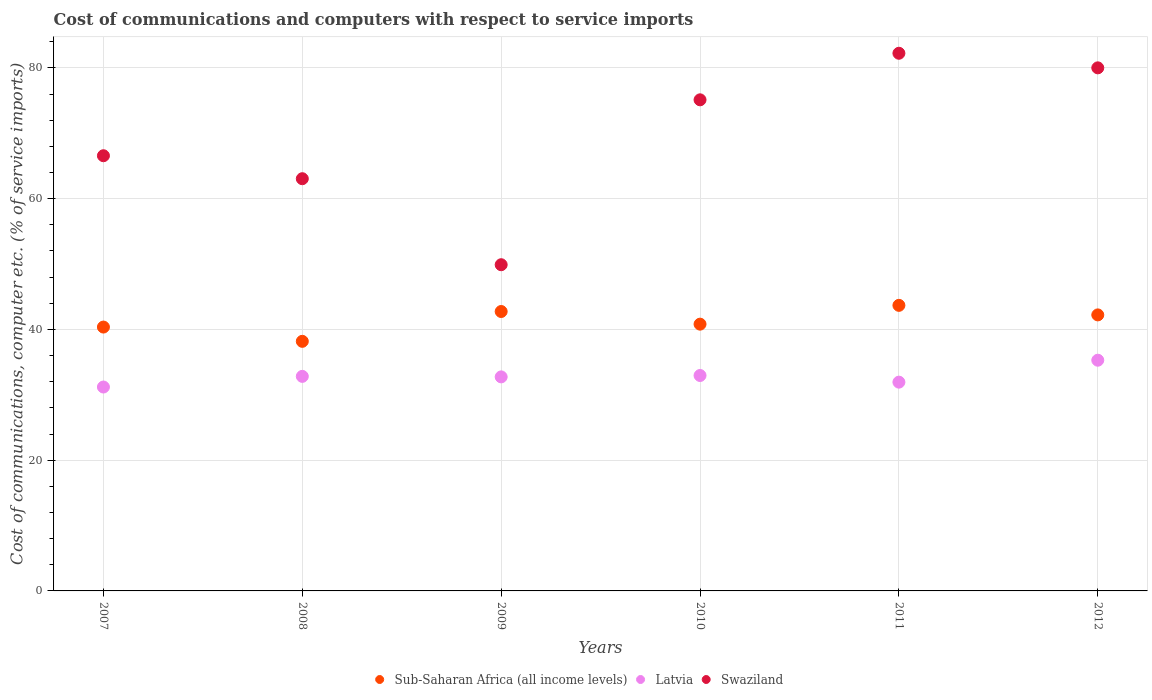How many different coloured dotlines are there?
Your answer should be compact. 3. Is the number of dotlines equal to the number of legend labels?
Your answer should be compact. Yes. What is the cost of communications and computers in Swaziland in 2009?
Provide a succinct answer. 49.9. Across all years, what is the maximum cost of communications and computers in Sub-Saharan Africa (all income levels)?
Your answer should be compact. 43.68. Across all years, what is the minimum cost of communications and computers in Swaziland?
Your answer should be compact. 49.9. In which year was the cost of communications and computers in Swaziland maximum?
Your response must be concise. 2011. In which year was the cost of communications and computers in Latvia minimum?
Your answer should be very brief. 2007. What is the total cost of communications and computers in Sub-Saharan Africa (all income levels) in the graph?
Provide a succinct answer. 248. What is the difference between the cost of communications and computers in Latvia in 2008 and that in 2011?
Offer a terse response. 0.88. What is the difference between the cost of communications and computers in Sub-Saharan Africa (all income levels) in 2008 and the cost of communications and computers in Latvia in 2009?
Keep it short and to the point. 5.44. What is the average cost of communications and computers in Sub-Saharan Africa (all income levels) per year?
Give a very brief answer. 41.33. In the year 2009, what is the difference between the cost of communications and computers in Sub-Saharan Africa (all income levels) and cost of communications and computers in Latvia?
Make the answer very short. 10. In how many years, is the cost of communications and computers in Latvia greater than 4 %?
Your response must be concise. 6. What is the ratio of the cost of communications and computers in Latvia in 2007 to that in 2012?
Offer a terse response. 0.88. Is the difference between the cost of communications and computers in Sub-Saharan Africa (all income levels) in 2007 and 2008 greater than the difference between the cost of communications and computers in Latvia in 2007 and 2008?
Your response must be concise. Yes. What is the difference between the highest and the second highest cost of communications and computers in Sub-Saharan Africa (all income levels)?
Your answer should be very brief. 0.94. What is the difference between the highest and the lowest cost of communications and computers in Latvia?
Provide a succinct answer. 4.1. Is the cost of communications and computers in Latvia strictly greater than the cost of communications and computers in Swaziland over the years?
Ensure brevity in your answer.  No. Are the values on the major ticks of Y-axis written in scientific E-notation?
Give a very brief answer. No. Does the graph contain grids?
Make the answer very short. Yes. How are the legend labels stacked?
Your answer should be compact. Horizontal. What is the title of the graph?
Offer a very short reply. Cost of communications and computers with respect to service imports. Does "Nepal" appear as one of the legend labels in the graph?
Your answer should be very brief. No. What is the label or title of the X-axis?
Make the answer very short. Years. What is the label or title of the Y-axis?
Offer a terse response. Cost of communications, computer etc. (% of service imports). What is the Cost of communications, computer etc. (% of service imports) of Sub-Saharan Africa (all income levels) in 2007?
Ensure brevity in your answer.  40.36. What is the Cost of communications, computer etc. (% of service imports) of Latvia in 2007?
Provide a succinct answer. 31.19. What is the Cost of communications, computer etc. (% of service imports) in Swaziland in 2007?
Offer a very short reply. 66.57. What is the Cost of communications, computer etc. (% of service imports) of Sub-Saharan Africa (all income levels) in 2008?
Give a very brief answer. 38.18. What is the Cost of communications, computer etc. (% of service imports) in Latvia in 2008?
Offer a terse response. 32.82. What is the Cost of communications, computer etc. (% of service imports) in Swaziland in 2008?
Make the answer very short. 63.06. What is the Cost of communications, computer etc. (% of service imports) in Sub-Saharan Africa (all income levels) in 2009?
Give a very brief answer. 42.74. What is the Cost of communications, computer etc. (% of service imports) of Latvia in 2009?
Ensure brevity in your answer.  32.74. What is the Cost of communications, computer etc. (% of service imports) in Swaziland in 2009?
Your answer should be very brief. 49.9. What is the Cost of communications, computer etc. (% of service imports) of Sub-Saharan Africa (all income levels) in 2010?
Ensure brevity in your answer.  40.81. What is the Cost of communications, computer etc. (% of service imports) in Latvia in 2010?
Provide a succinct answer. 32.95. What is the Cost of communications, computer etc. (% of service imports) of Swaziland in 2010?
Your answer should be very brief. 75.13. What is the Cost of communications, computer etc. (% of service imports) in Sub-Saharan Africa (all income levels) in 2011?
Ensure brevity in your answer.  43.68. What is the Cost of communications, computer etc. (% of service imports) in Latvia in 2011?
Ensure brevity in your answer.  31.94. What is the Cost of communications, computer etc. (% of service imports) of Swaziland in 2011?
Your response must be concise. 82.25. What is the Cost of communications, computer etc. (% of service imports) of Sub-Saharan Africa (all income levels) in 2012?
Ensure brevity in your answer.  42.22. What is the Cost of communications, computer etc. (% of service imports) of Latvia in 2012?
Provide a succinct answer. 35.29. What is the Cost of communications, computer etc. (% of service imports) in Swaziland in 2012?
Offer a terse response. 80.02. Across all years, what is the maximum Cost of communications, computer etc. (% of service imports) in Sub-Saharan Africa (all income levels)?
Ensure brevity in your answer.  43.68. Across all years, what is the maximum Cost of communications, computer etc. (% of service imports) in Latvia?
Give a very brief answer. 35.29. Across all years, what is the maximum Cost of communications, computer etc. (% of service imports) of Swaziland?
Your response must be concise. 82.25. Across all years, what is the minimum Cost of communications, computer etc. (% of service imports) of Sub-Saharan Africa (all income levels)?
Make the answer very short. 38.18. Across all years, what is the minimum Cost of communications, computer etc. (% of service imports) in Latvia?
Your answer should be very brief. 31.19. Across all years, what is the minimum Cost of communications, computer etc. (% of service imports) in Swaziland?
Give a very brief answer. 49.9. What is the total Cost of communications, computer etc. (% of service imports) in Sub-Saharan Africa (all income levels) in the graph?
Your response must be concise. 248. What is the total Cost of communications, computer etc. (% of service imports) of Latvia in the graph?
Make the answer very short. 196.94. What is the total Cost of communications, computer etc. (% of service imports) in Swaziland in the graph?
Keep it short and to the point. 416.92. What is the difference between the Cost of communications, computer etc. (% of service imports) of Sub-Saharan Africa (all income levels) in 2007 and that in 2008?
Give a very brief answer. 2.18. What is the difference between the Cost of communications, computer etc. (% of service imports) of Latvia in 2007 and that in 2008?
Your answer should be compact. -1.63. What is the difference between the Cost of communications, computer etc. (% of service imports) of Swaziland in 2007 and that in 2008?
Offer a terse response. 3.51. What is the difference between the Cost of communications, computer etc. (% of service imports) in Sub-Saharan Africa (all income levels) in 2007 and that in 2009?
Offer a terse response. -2.38. What is the difference between the Cost of communications, computer etc. (% of service imports) in Latvia in 2007 and that in 2009?
Your answer should be compact. -1.55. What is the difference between the Cost of communications, computer etc. (% of service imports) of Swaziland in 2007 and that in 2009?
Give a very brief answer. 16.67. What is the difference between the Cost of communications, computer etc. (% of service imports) of Sub-Saharan Africa (all income levels) in 2007 and that in 2010?
Provide a short and direct response. -0.45. What is the difference between the Cost of communications, computer etc. (% of service imports) in Latvia in 2007 and that in 2010?
Make the answer very short. -1.76. What is the difference between the Cost of communications, computer etc. (% of service imports) in Swaziland in 2007 and that in 2010?
Give a very brief answer. -8.55. What is the difference between the Cost of communications, computer etc. (% of service imports) of Sub-Saharan Africa (all income levels) in 2007 and that in 2011?
Your response must be concise. -3.32. What is the difference between the Cost of communications, computer etc. (% of service imports) of Latvia in 2007 and that in 2011?
Your response must be concise. -0.75. What is the difference between the Cost of communications, computer etc. (% of service imports) of Swaziland in 2007 and that in 2011?
Ensure brevity in your answer.  -15.68. What is the difference between the Cost of communications, computer etc. (% of service imports) of Sub-Saharan Africa (all income levels) in 2007 and that in 2012?
Provide a succinct answer. -1.86. What is the difference between the Cost of communications, computer etc. (% of service imports) of Latvia in 2007 and that in 2012?
Ensure brevity in your answer.  -4.1. What is the difference between the Cost of communications, computer etc. (% of service imports) in Swaziland in 2007 and that in 2012?
Provide a succinct answer. -13.44. What is the difference between the Cost of communications, computer etc. (% of service imports) in Sub-Saharan Africa (all income levels) in 2008 and that in 2009?
Make the answer very short. -4.56. What is the difference between the Cost of communications, computer etc. (% of service imports) in Latvia in 2008 and that in 2009?
Your answer should be compact. 0.08. What is the difference between the Cost of communications, computer etc. (% of service imports) of Swaziland in 2008 and that in 2009?
Your answer should be compact. 13.16. What is the difference between the Cost of communications, computer etc. (% of service imports) of Sub-Saharan Africa (all income levels) in 2008 and that in 2010?
Ensure brevity in your answer.  -2.63. What is the difference between the Cost of communications, computer etc. (% of service imports) of Latvia in 2008 and that in 2010?
Your answer should be compact. -0.13. What is the difference between the Cost of communications, computer etc. (% of service imports) of Swaziland in 2008 and that in 2010?
Your answer should be very brief. -12.07. What is the difference between the Cost of communications, computer etc. (% of service imports) of Sub-Saharan Africa (all income levels) in 2008 and that in 2011?
Keep it short and to the point. -5.5. What is the difference between the Cost of communications, computer etc. (% of service imports) in Latvia in 2008 and that in 2011?
Ensure brevity in your answer.  0.88. What is the difference between the Cost of communications, computer etc. (% of service imports) of Swaziland in 2008 and that in 2011?
Provide a short and direct response. -19.19. What is the difference between the Cost of communications, computer etc. (% of service imports) of Sub-Saharan Africa (all income levels) in 2008 and that in 2012?
Give a very brief answer. -4.04. What is the difference between the Cost of communications, computer etc. (% of service imports) in Latvia in 2008 and that in 2012?
Your response must be concise. -2.47. What is the difference between the Cost of communications, computer etc. (% of service imports) of Swaziland in 2008 and that in 2012?
Offer a very short reply. -16.96. What is the difference between the Cost of communications, computer etc. (% of service imports) in Sub-Saharan Africa (all income levels) in 2009 and that in 2010?
Provide a short and direct response. 1.93. What is the difference between the Cost of communications, computer etc. (% of service imports) in Latvia in 2009 and that in 2010?
Offer a terse response. -0.21. What is the difference between the Cost of communications, computer etc. (% of service imports) in Swaziland in 2009 and that in 2010?
Offer a very short reply. -25.23. What is the difference between the Cost of communications, computer etc. (% of service imports) in Sub-Saharan Africa (all income levels) in 2009 and that in 2011?
Your answer should be very brief. -0.94. What is the difference between the Cost of communications, computer etc. (% of service imports) in Latvia in 2009 and that in 2011?
Ensure brevity in your answer.  0.81. What is the difference between the Cost of communications, computer etc. (% of service imports) in Swaziland in 2009 and that in 2011?
Ensure brevity in your answer.  -32.35. What is the difference between the Cost of communications, computer etc. (% of service imports) in Sub-Saharan Africa (all income levels) in 2009 and that in 2012?
Your answer should be compact. 0.52. What is the difference between the Cost of communications, computer etc. (% of service imports) in Latvia in 2009 and that in 2012?
Keep it short and to the point. -2.55. What is the difference between the Cost of communications, computer etc. (% of service imports) of Swaziland in 2009 and that in 2012?
Make the answer very short. -30.12. What is the difference between the Cost of communications, computer etc. (% of service imports) of Sub-Saharan Africa (all income levels) in 2010 and that in 2011?
Offer a very short reply. -2.88. What is the difference between the Cost of communications, computer etc. (% of service imports) in Latvia in 2010 and that in 2011?
Ensure brevity in your answer.  1.02. What is the difference between the Cost of communications, computer etc. (% of service imports) in Swaziland in 2010 and that in 2011?
Provide a succinct answer. -7.12. What is the difference between the Cost of communications, computer etc. (% of service imports) in Sub-Saharan Africa (all income levels) in 2010 and that in 2012?
Provide a succinct answer. -1.42. What is the difference between the Cost of communications, computer etc. (% of service imports) of Latvia in 2010 and that in 2012?
Your answer should be compact. -2.34. What is the difference between the Cost of communications, computer etc. (% of service imports) of Swaziland in 2010 and that in 2012?
Make the answer very short. -4.89. What is the difference between the Cost of communications, computer etc. (% of service imports) in Sub-Saharan Africa (all income levels) in 2011 and that in 2012?
Give a very brief answer. 1.46. What is the difference between the Cost of communications, computer etc. (% of service imports) of Latvia in 2011 and that in 2012?
Offer a very short reply. -3.36. What is the difference between the Cost of communications, computer etc. (% of service imports) in Swaziland in 2011 and that in 2012?
Offer a terse response. 2.23. What is the difference between the Cost of communications, computer etc. (% of service imports) in Sub-Saharan Africa (all income levels) in 2007 and the Cost of communications, computer etc. (% of service imports) in Latvia in 2008?
Keep it short and to the point. 7.54. What is the difference between the Cost of communications, computer etc. (% of service imports) in Sub-Saharan Africa (all income levels) in 2007 and the Cost of communications, computer etc. (% of service imports) in Swaziland in 2008?
Ensure brevity in your answer.  -22.69. What is the difference between the Cost of communications, computer etc. (% of service imports) in Latvia in 2007 and the Cost of communications, computer etc. (% of service imports) in Swaziland in 2008?
Your answer should be compact. -31.87. What is the difference between the Cost of communications, computer etc. (% of service imports) in Sub-Saharan Africa (all income levels) in 2007 and the Cost of communications, computer etc. (% of service imports) in Latvia in 2009?
Ensure brevity in your answer.  7.62. What is the difference between the Cost of communications, computer etc. (% of service imports) in Sub-Saharan Africa (all income levels) in 2007 and the Cost of communications, computer etc. (% of service imports) in Swaziland in 2009?
Provide a succinct answer. -9.54. What is the difference between the Cost of communications, computer etc. (% of service imports) of Latvia in 2007 and the Cost of communications, computer etc. (% of service imports) of Swaziland in 2009?
Provide a succinct answer. -18.71. What is the difference between the Cost of communications, computer etc. (% of service imports) of Sub-Saharan Africa (all income levels) in 2007 and the Cost of communications, computer etc. (% of service imports) of Latvia in 2010?
Provide a succinct answer. 7.41. What is the difference between the Cost of communications, computer etc. (% of service imports) of Sub-Saharan Africa (all income levels) in 2007 and the Cost of communications, computer etc. (% of service imports) of Swaziland in 2010?
Provide a succinct answer. -34.76. What is the difference between the Cost of communications, computer etc. (% of service imports) in Latvia in 2007 and the Cost of communications, computer etc. (% of service imports) in Swaziland in 2010?
Ensure brevity in your answer.  -43.93. What is the difference between the Cost of communications, computer etc. (% of service imports) in Sub-Saharan Africa (all income levels) in 2007 and the Cost of communications, computer etc. (% of service imports) in Latvia in 2011?
Offer a very short reply. 8.43. What is the difference between the Cost of communications, computer etc. (% of service imports) of Sub-Saharan Africa (all income levels) in 2007 and the Cost of communications, computer etc. (% of service imports) of Swaziland in 2011?
Keep it short and to the point. -41.88. What is the difference between the Cost of communications, computer etc. (% of service imports) in Latvia in 2007 and the Cost of communications, computer etc. (% of service imports) in Swaziland in 2011?
Ensure brevity in your answer.  -51.06. What is the difference between the Cost of communications, computer etc. (% of service imports) in Sub-Saharan Africa (all income levels) in 2007 and the Cost of communications, computer etc. (% of service imports) in Latvia in 2012?
Make the answer very short. 5.07. What is the difference between the Cost of communications, computer etc. (% of service imports) in Sub-Saharan Africa (all income levels) in 2007 and the Cost of communications, computer etc. (% of service imports) in Swaziland in 2012?
Make the answer very short. -39.65. What is the difference between the Cost of communications, computer etc. (% of service imports) of Latvia in 2007 and the Cost of communications, computer etc. (% of service imports) of Swaziland in 2012?
Offer a very short reply. -48.83. What is the difference between the Cost of communications, computer etc. (% of service imports) of Sub-Saharan Africa (all income levels) in 2008 and the Cost of communications, computer etc. (% of service imports) of Latvia in 2009?
Your answer should be compact. 5.44. What is the difference between the Cost of communications, computer etc. (% of service imports) of Sub-Saharan Africa (all income levels) in 2008 and the Cost of communications, computer etc. (% of service imports) of Swaziland in 2009?
Give a very brief answer. -11.72. What is the difference between the Cost of communications, computer etc. (% of service imports) of Latvia in 2008 and the Cost of communications, computer etc. (% of service imports) of Swaziland in 2009?
Provide a short and direct response. -17.08. What is the difference between the Cost of communications, computer etc. (% of service imports) in Sub-Saharan Africa (all income levels) in 2008 and the Cost of communications, computer etc. (% of service imports) in Latvia in 2010?
Provide a succinct answer. 5.23. What is the difference between the Cost of communications, computer etc. (% of service imports) in Sub-Saharan Africa (all income levels) in 2008 and the Cost of communications, computer etc. (% of service imports) in Swaziland in 2010?
Provide a short and direct response. -36.95. What is the difference between the Cost of communications, computer etc. (% of service imports) of Latvia in 2008 and the Cost of communications, computer etc. (% of service imports) of Swaziland in 2010?
Keep it short and to the point. -42.31. What is the difference between the Cost of communications, computer etc. (% of service imports) in Sub-Saharan Africa (all income levels) in 2008 and the Cost of communications, computer etc. (% of service imports) in Latvia in 2011?
Give a very brief answer. 6.24. What is the difference between the Cost of communications, computer etc. (% of service imports) in Sub-Saharan Africa (all income levels) in 2008 and the Cost of communications, computer etc. (% of service imports) in Swaziland in 2011?
Give a very brief answer. -44.07. What is the difference between the Cost of communications, computer etc. (% of service imports) in Latvia in 2008 and the Cost of communications, computer etc. (% of service imports) in Swaziland in 2011?
Your answer should be compact. -49.43. What is the difference between the Cost of communications, computer etc. (% of service imports) in Sub-Saharan Africa (all income levels) in 2008 and the Cost of communications, computer etc. (% of service imports) in Latvia in 2012?
Ensure brevity in your answer.  2.89. What is the difference between the Cost of communications, computer etc. (% of service imports) of Sub-Saharan Africa (all income levels) in 2008 and the Cost of communications, computer etc. (% of service imports) of Swaziland in 2012?
Your answer should be compact. -41.84. What is the difference between the Cost of communications, computer etc. (% of service imports) in Latvia in 2008 and the Cost of communications, computer etc. (% of service imports) in Swaziland in 2012?
Ensure brevity in your answer.  -47.2. What is the difference between the Cost of communications, computer etc. (% of service imports) in Sub-Saharan Africa (all income levels) in 2009 and the Cost of communications, computer etc. (% of service imports) in Latvia in 2010?
Keep it short and to the point. 9.79. What is the difference between the Cost of communications, computer etc. (% of service imports) of Sub-Saharan Africa (all income levels) in 2009 and the Cost of communications, computer etc. (% of service imports) of Swaziland in 2010?
Offer a terse response. -32.38. What is the difference between the Cost of communications, computer etc. (% of service imports) in Latvia in 2009 and the Cost of communications, computer etc. (% of service imports) in Swaziland in 2010?
Your answer should be very brief. -42.38. What is the difference between the Cost of communications, computer etc. (% of service imports) in Sub-Saharan Africa (all income levels) in 2009 and the Cost of communications, computer etc. (% of service imports) in Latvia in 2011?
Offer a very short reply. 10.81. What is the difference between the Cost of communications, computer etc. (% of service imports) in Sub-Saharan Africa (all income levels) in 2009 and the Cost of communications, computer etc. (% of service imports) in Swaziland in 2011?
Keep it short and to the point. -39.51. What is the difference between the Cost of communications, computer etc. (% of service imports) of Latvia in 2009 and the Cost of communications, computer etc. (% of service imports) of Swaziland in 2011?
Your answer should be very brief. -49.51. What is the difference between the Cost of communications, computer etc. (% of service imports) of Sub-Saharan Africa (all income levels) in 2009 and the Cost of communications, computer etc. (% of service imports) of Latvia in 2012?
Offer a very short reply. 7.45. What is the difference between the Cost of communications, computer etc. (% of service imports) of Sub-Saharan Africa (all income levels) in 2009 and the Cost of communications, computer etc. (% of service imports) of Swaziland in 2012?
Your answer should be compact. -37.27. What is the difference between the Cost of communications, computer etc. (% of service imports) in Latvia in 2009 and the Cost of communications, computer etc. (% of service imports) in Swaziland in 2012?
Make the answer very short. -47.27. What is the difference between the Cost of communications, computer etc. (% of service imports) in Sub-Saharan Africa (all income levels) in 2010 and the Cost of communications, computer etc. (% of service imports) in Latvia in 2011?
Give a very brief answer. 8.87. What is the difference between the Cost of communications, computer etc. (% of service imports) of Sub-Saharan Africa (all income levels) in 2010 and the Cost of communications, computer etc. (% of service imports) of Swaziland in 2011?
Give a very brief answer. -41.44. What is the difference between the Cost of communications, computer etc. (% of service imports) of Latvia in 2010 and the Cost of communications, computer etc. (% of service imports) of Swaziland in 2011?
Your response must be concise. -49.29. What is the difference between the Cost of communications, computer etc. (% of service imports) in Sub-Saharan Africa (all income levels) in 2010 and the Cost of communications, computer etc. (% of service imports) in Latvia in 2012?
Provide a succinct answer. 5.52. What is the difference between the Cost of communications, computer etc. (% of service imports) in Sub-Saharan Africa (all income levels) in 2010 and the Cost of communications, computer etc. (% of service imports) in Swaziland in 2012?
Provide a succinct answer. -39.21. What is the difference between the Cost of communications, computer etc. (% of service imports) of Latvia in 2010 and the Cost of communications, computer etc. (% of service imports) of Swaziland in 2012?
Offer a very short reply. -47.06. What is the difference between the Cost of communications, computer etc. (% of service imports) in Sub-Saharan Africa (all income levels) in 2011 and the Cost of communications, computer etc. (% of service imports) in Latvia in 2012?
Your response must be concise. 8.39. What is the difference between the Cost of communications, computer etc. (% of service imports) in Sub-Saharan Africa (all income levels) in 2011 and the Cost of communications, computer etc. (% of service imports) in Swaziland in 2012?
Your answer should be compact. -36.33. What is the difference between the Cost of communications, computer etc. (% of service imports) in Latvia in 2011 and the Cost of communications, computer etc. (% of service imports) in Swaziland in 2012?
Your response must be concise. -48.08. What is the average Cost of communications, computer etc. (% of service imports) in Sub-Saharan Africa (all income levels) per year?
Provide a succinct answer. 41.33. What is the average Cost of communications, computer etc. (% of service imports) in Latvia per year?
Provide a succinct answer. 32.82. What is the average Cost of communications, computer etc. (% of service imports) in Swaziland per year?
Keep it short and to the point. 69.49. In the year 2007, what is the difference between the Cost of communications, computer etc. (% of service imports) in Sub-Saharan Africa (all income levels) and Cost of communications, computer etc. (% of service imports) in Latvia?
Give a very brief answer. 9.17. In the year 2007, what is the difference between the Cost of communications, computer etc. (% of service imports) in Sub-Saharan Africa (all income levels) and Cost of communications, computer etc. (% of service imports) in Swaziland?
Your response must be concise. -26.21. In the year 2007, what is the difference between the Cost of communications, computer etc. (% of service imports) in Latvia and Cost of communications, computer etc. (% of service imports) in Swaziland?
Keep it short and to the point. -35.38. In the year 2008, what is the difference between the Cost of communications, computer etc. (% of service imports) of Sub-Saharan Africa (all income levels) and Cost of communications, computer etc. (% of service imports) of Latvia?
Offer a terse response. 5.36. In the year 2008, what is the difference between the Cost of communications, computer etc. (% of service imports) of Sub-Saharan Africa (all income levels) and Cost of communications, computer etc. (% of service imports) of Swaziland?
Offer a very short reply. -24.88. In the year 2008, what is the difference between the Cost of communications, computer etc. (% of service imports) of Latvia and Cost of communications, computer etc. (% of service imports) of Swaziland?
Provide a succinct answer. -30.24. In the year 2009, what is the difference between the Cost of communications, computer etc. (% of service imports) in Sub-Saharan Africa (all income levels) and Cost of communications, computer etc. (% of service imports) in Latvia?
Ensure brevity in your answer.  10. In the year 2009, what is the difference between the Cost of communications, computer etc. (% of service imports) of Sub-Saharan Africa (all income levels) and Cost of communications, computer etc. (% of service imports) of Swaziland?
Provide a short and direct response. -7.16. In the year 2009, what is the difference between the Cost of communications, computer etc. (% of service imports) of Latvia and Cost of communications, computer etc. (% of service imports) of Swaziland?
Make the answer very short. -17.16. In the year 2010, what is the difference between the Cost of communications, computer etc. (% of service imports) in Sub-Saharan Africa (all income levels) and Cost of communications, computer etc. (% of service imports) in Latvia?
Your response must be concise. 7.85. In the year 2010, what is the difference between the Cost of communications, computer etc. (% of service imports) in Sub-Saharan Africa (all income levels) and Cost of communications, computer etc. (% of service imports) in Swaziland?
Provide a succinct answer. -34.32. In the year 2010, what is the difference between the Cost of communications, computer etc. (% of service imports) in Latvia and Cost of communications, computer etc. (% of service imports) in Swaziland?
Keep it short and to the point. -42.17. In the year 2011, what is the difference between the Cost of communications, computer etc. (% of service imports) of Sub-Saharan Africa (all income levels) and Cost of communications, computer etc. (% of service imports) of Latvia?
Offer a terse response. 11.75. In the year 2011, what is the difference between the Cost of communications, computer etc. (% of service imports) in Sub-Saharan Africa (all income levels) and Cost of communications, computer etc. (% of service imports) in Swaziland?
Your response must be concise. -38.56. In the year 2011, what is the difference between the Cost of communications, computer etc. (% of service imports) of Latvia and Cost of communications, computer etc. (% of service imports) of Swaziland?
Provide a short and direct response. -50.31. In the year 2012, what is the difference between the Cost of communications, computer etc. (% of service imports) in Sub-Saharan Africa (all income levels) and Cost of communications, computer etc. (% of service imports) in Latvia?
Provide a succinct answer. 6.93. In the year 2012, what is the difference between the Cost of communications, computer etc. (% of service imports) in Sub-Saharan Africa (all income levels) and Cost of communications, computer etc. (% of service imports) in Swaziland?
Your answer should be very brief. -37.79. In the year 2012, what is the difference between the Cost of communications, computer etc. (% of service imports) of Latvia and Cost of communications, computer etc. (% of service imports) of Swaziland?
Ensure brevity in your answer.  -44.72. What is the ratio of the Cost of communications, computer etc. (% of service imports) in Sub-Saharan Africa (all income levels) in 2007 to that in 2008?
Provide a succinct answer. 1.06. What is the ratio of the Cost of communications, computer etc. (% of service imports) of Latvia in 2007 to that in 2008?
Your answer should be compact. 0.95. What is the ratio of the Cost of communications, computer etc. (% of service imports) in Swaziland in 2007 to that in 2008?
Provide a succinct answer. 1.06. What is the ratio of the Cost of communications, computer etc. (% of service imports) of Sub-Saharan Africa (all income levels) in 2007 to that in 2009?
Your response must be concise. 0.94. What is the ratio of the Cost of communications, computer etc. (% of service imports) of Latvia in 2007 to that in 2009?
Offer a terse response. 0.95. What is the ratio of the Cost of communications, computer etc. (% of service imports) in Swaziland in 2007 to that in 2009?
Your answer should be very brief. 1.33. What is the ratio of the Cost of communications, computer etc. (% of service imports) of Sub-Saharan Africa (all income levels) in 2007 to that in 2010?
Keep it short and to the point. 0.99. What is the ratio of the Cost of communications, computer etc. (% of service imports) of Latvia in 2007 to that in 2010?
Offer a very short reply. 0.95. What is the ratio of the Cost of communications, computer etc. (% of service imports) of Swaziland in 2007 to that in 2010?
Your answer should be compact. 0.89. What is the ratio of the Cost of communications, computer etc. (% of service imports) of Sub-Saharan Africa (all income levels) in 2007 to that in 2011?
Your response must be concise. 0.92. What is the ratio of the Cost of communications, computer etc. (% of service imports) of Latvia in 2007 to that in 2011?
Make the answer very short. 0.98. What is the ratio of the Cost of communications, computer etc. (% of service imports) in Swaziland in 2007 to that in 2011?
Provide a succinct answer. 0.81. What is the ratio of the Cost of communications, computer etc. (% of service imports) of Sub-Saharan Africa (all income levels) in 2007 to that in 2012?
Give a very brief answer. 0.96. What is the ratio of the Cost of communications, computer etc. (% of service imports) of Latvia in 2007 to that in 2012?
Offer a terse response. 0.88. What is the ratio of the Cost of communications, computer etc. (% of service imports) of Swaziland in 2007 to that in 2012?
Give a very brief answer. 0.83. What is the ratio of the Cost of communications, computer etc. (% of service imports) of Sub-Saharan Africa (all income levels) in 2008 to that in 2009?
Offer a very short reply. 0.89. What is the ratio of the Cost of communications, computer etc. (% of service imports) of Swaziland in 2008 to that in 2009?
Your answer should be compact. 1.26. What is the ratio of the Cost of communications, computer etc. (% of service imports) of Sub-Saharan Africa (all income levels) in 2008 to that in 2010?
Keep it short and to the point. 0.94. What is the ratio of the Cost of communications, computer etc. (% of service imports) of Swaziland in 2008 to that in 2010?
Your answer should be very brief. 0.84. What is the ratio of the Cost of communications, computer etc. (% of service imports) in Sub-Saharan Africa (all income levels) in 2008 to that in 2011?
Keep it short and to the point. 0.87. What is the ratio of the Cost of communications, computer etc. (% of service imports) of Latvia in 2008 to that in 2011?
Your response must be concise. 1.03. What is the ratio of the Cost of communications, computer etc. (% of service imports) of Swaziland in 2008 to that in 2011?
Make the answer very short. 0.77. What is the ratio of the Cost of communications, computer etc. (% of service imports) in Sub-Saharan Africa (all income levels) in 2008 to that in 2012?
Offer a very short reply. 0.9. What is the ratio of the Cost of communications, computer etc. (% of service imports) in Swaziland in 2008 to that in 2012?
Give a very brief answer. 0.79. What is the ratio of the Cost of communications, computer etc. (% of service imports) in Sub-Saharan Africa (all income levels) in 2009 to that in 2010?
Offer a terse response. 1.05. What is the ratio of the Cost of communications, computer etc. (% of service imports) in Swaziland in 2009 to that in 2010?
Provide a succinct answer. 0.66. What is the ratio of the Cost of communications, computer etc. (% of service imports) in Sub-Saharan Africa (all income levels) in 2009 to that in 2011?
Provide a succinct answer. 0.98. What is the ratio of the Cost of communications, computer etc. (% of service imports) of Latvia in 2009 to that in 2011?
Make the answer very short. 1.03. What is the ratio of the Cost of communications, computer etc. (% of service imports) in Swaziland in 2009 to that in 2011?
Make the answer very short. 0.61. What is the ratio of the Cost of communications, computer etc. (% of service imports) of Sub-Saharan Africa (all income levels) in 2009 to that in 2012?
Give a very brief answer. 1.01. What is the ratio of the Cost of communications, computer etc. (% of service imports) of Latvia in 2009 to that in 2012?
Provide a succinct answer. 0.93. What is the ratio of the Cost of communications, computer etc. (% of service imports) in Swaziland in 2009 to that in 2012?
Offer a very short reply. 0.62. What is the ratio of the Cost of communications, computer etc. (% of service imports) in Sub-Saharan Africa (all income levels) in 2010 to that in 2011?
Provide a succinct answer. 0.93. What is the ratio of the Cost of communications, computer etc. (% of service imports) of Latvia in 2010 to that in 2011?
Keep it short and to the point. 1.03. What is the ratio of the Cost of communications, computer etc. (% of service imports) of Swaziland in 2010 to that in 2011?
Provide a succinct answer. 0.91. What is the ratio of the Cost of communications, computer etc. (% of service imports) of Sub-Saharan Africa (all income levels) in 2010 to that in 2012?
Your response must be concise. 0.97. What is the ratio of the Cost of communications, computer etc. (% of service imports) in Latvia in 2010 to that in 2012?
Make the answer very short. 0.93. What is the ratio of the Cost of communications, computer etc. (% of service imports) in Swaziland in 2010 to that in 2012?
Make the answer very short. 0.94. What is the ratio of the Cost of communications, computer etc. (% of service imports) of Sub-Saharan Africa (all income levels) in 2011 to that in 2012?
Your response must be concise. 1.03. What is the ratio of the Cost of communications, computer etc. (% of service imports) in Latvia in 2011 to that in 2012?
Offer a terse response. 0.9. What is the ratio of the Cost of communications, computer etc. (% of service imports) in Swaziland in 2011 to that in 2012?
Offer a very short reply. 1.03. What is the difference between the highest and the second highest Cost of communications, computer etc. (% of service imports) in Sub-Saharan Africa (all income levels)?
Make the answer very short. 0.94. What is the difference between the highest and the second highest Cost of communications, computer etc. (% of service imports) in Latvia?
Provide a succinct answer. 2.34. What is the difference between the highest and the second highest Cost of communications, computer etc. (% of service imports) of Swaziland?
Provide a short and direct response. 2.23. What is the difference between the highest and the lowest Cost of communications, computer etc. (% of service imports) in Sub-Saharan Africa (all income levels)?
Make the answer very short. 5.5. What is the difference between the highest and the lowest Cost of communications, computer etc. (% of service imports) in Latvia?
Give a very brief answer. 4.1. What is the difference between the highest and the lowest Cost of communications, computer etc. (% of service imports) in Swaziland?
Make the answer very short. 32.35. 